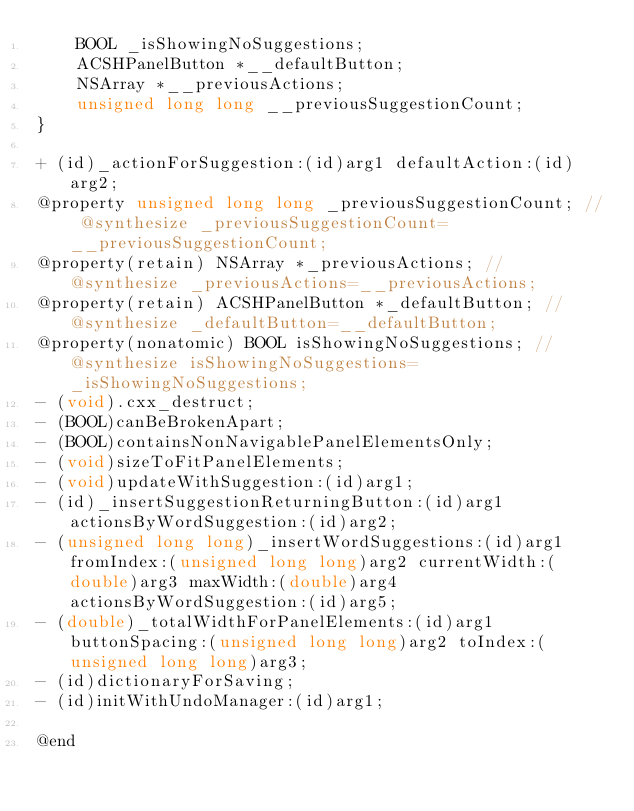Convert code to text. <code><loc_0><loc_0><loc_500><loc_500><_C_>    BOOL _isShowingNoSuggestions;
    ACSHPanelButton *__defaultButton;
    NSArray *__previousActions;
    unsigned long long __previousSuggestionCount;
}

+ (id)_actionForSuggestion:(id)arg1 defaultAction:(id)arg2;
@property unsigned long long _previousSuggestionCount; // @synthesize _previousSuggestionCount=__previousSuggestionCount;
@property(retain) NSArray *_previousActions; // @synthesize _previousActions=__previousActions;
@property(retain) ACSHPanelButton *_defaultButton; // @synthesize _defaultButton=__defaultButton;
@property(nonatomic) BOOL isShowingNoSuggestions; // @synthesize isShowingNoSuggestions=_isShowingNoSuggestions;
- (void).cxx_destruct;
- (BOOL)canBeBrokenApart;
- (BOOL)containsNonNavigablePanelElementsOnly;
- (void)sizeToFitPanelElements;
- (void)updateWithSuggestion:(id)arg1;
- (id)_insertSuggestionReturningButton:(id)arg1 actionsByWordSuggestion:(id)arg2;
- (unsigned long long)_insertWordSuggestions:(id)arg1 fromIndex:(unsigned long long)arg2 currentWidth:(double)arg3 maxWidth:(double)arg4 actionsByWordSuggestion:(id)arg5;
- (double)_totalWidthForPanelElements:(id)arg1 buttonSpacing:(unsigned long long)arg2 toIndex:(unsigned long long)arg3;
- (id)dictionaryForSaving;
- (id)initWithUndoManager:(id)arg1;

@end

</code> 